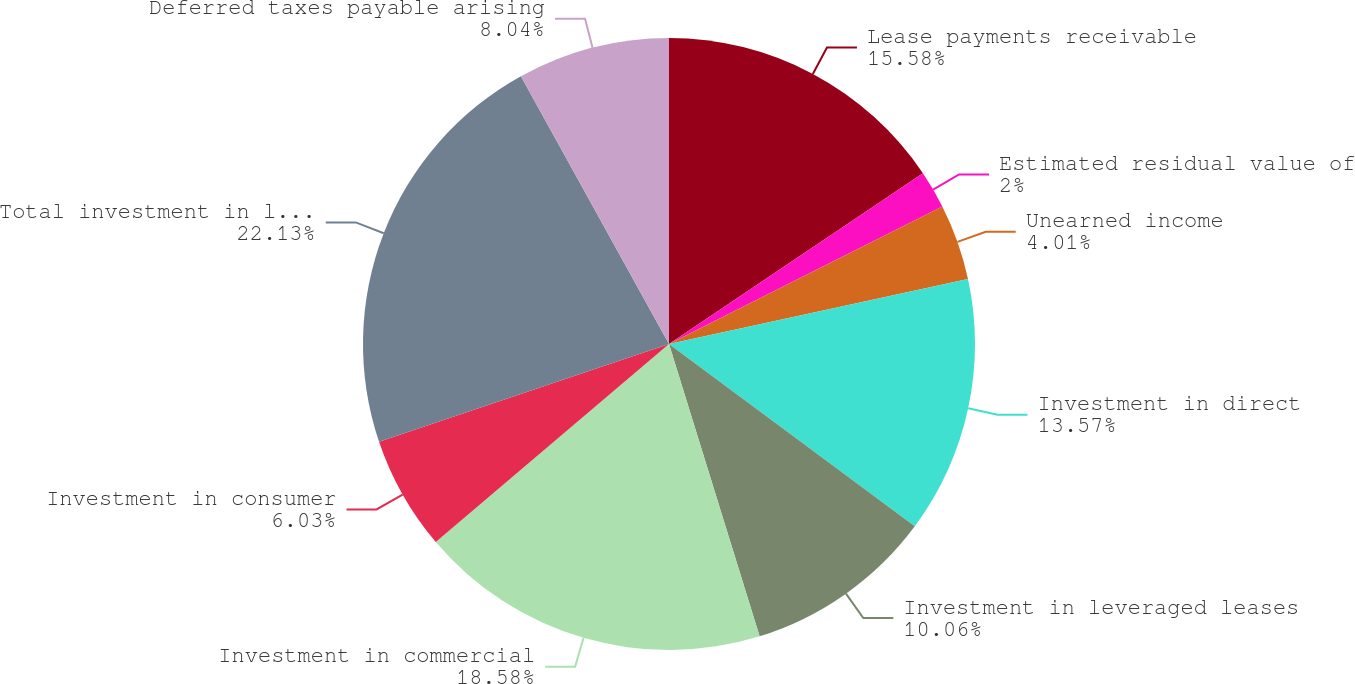<chart> <loc_0><loc_0><loc_500><loc_500><pie_chart><fcel>Lease payments receivable<fcel>Estimated residual value of<fcel>Unearned income<fcel>Investment in direct<fcel>Investment in leveraged leases<fcel>Investment in commercial<fcel>Investment in consumer<fcel>Total investment in leases<fcel>Deferred taxes payable arising<nl><fcel>15.58%<fcel>2.0%<fcel>4.01%<fcel>13.57%<fcel>10.06%<fcel>18.58%<fcel>6.03%<fcel>22.14%<fcel>8.04%<nl></chart> 